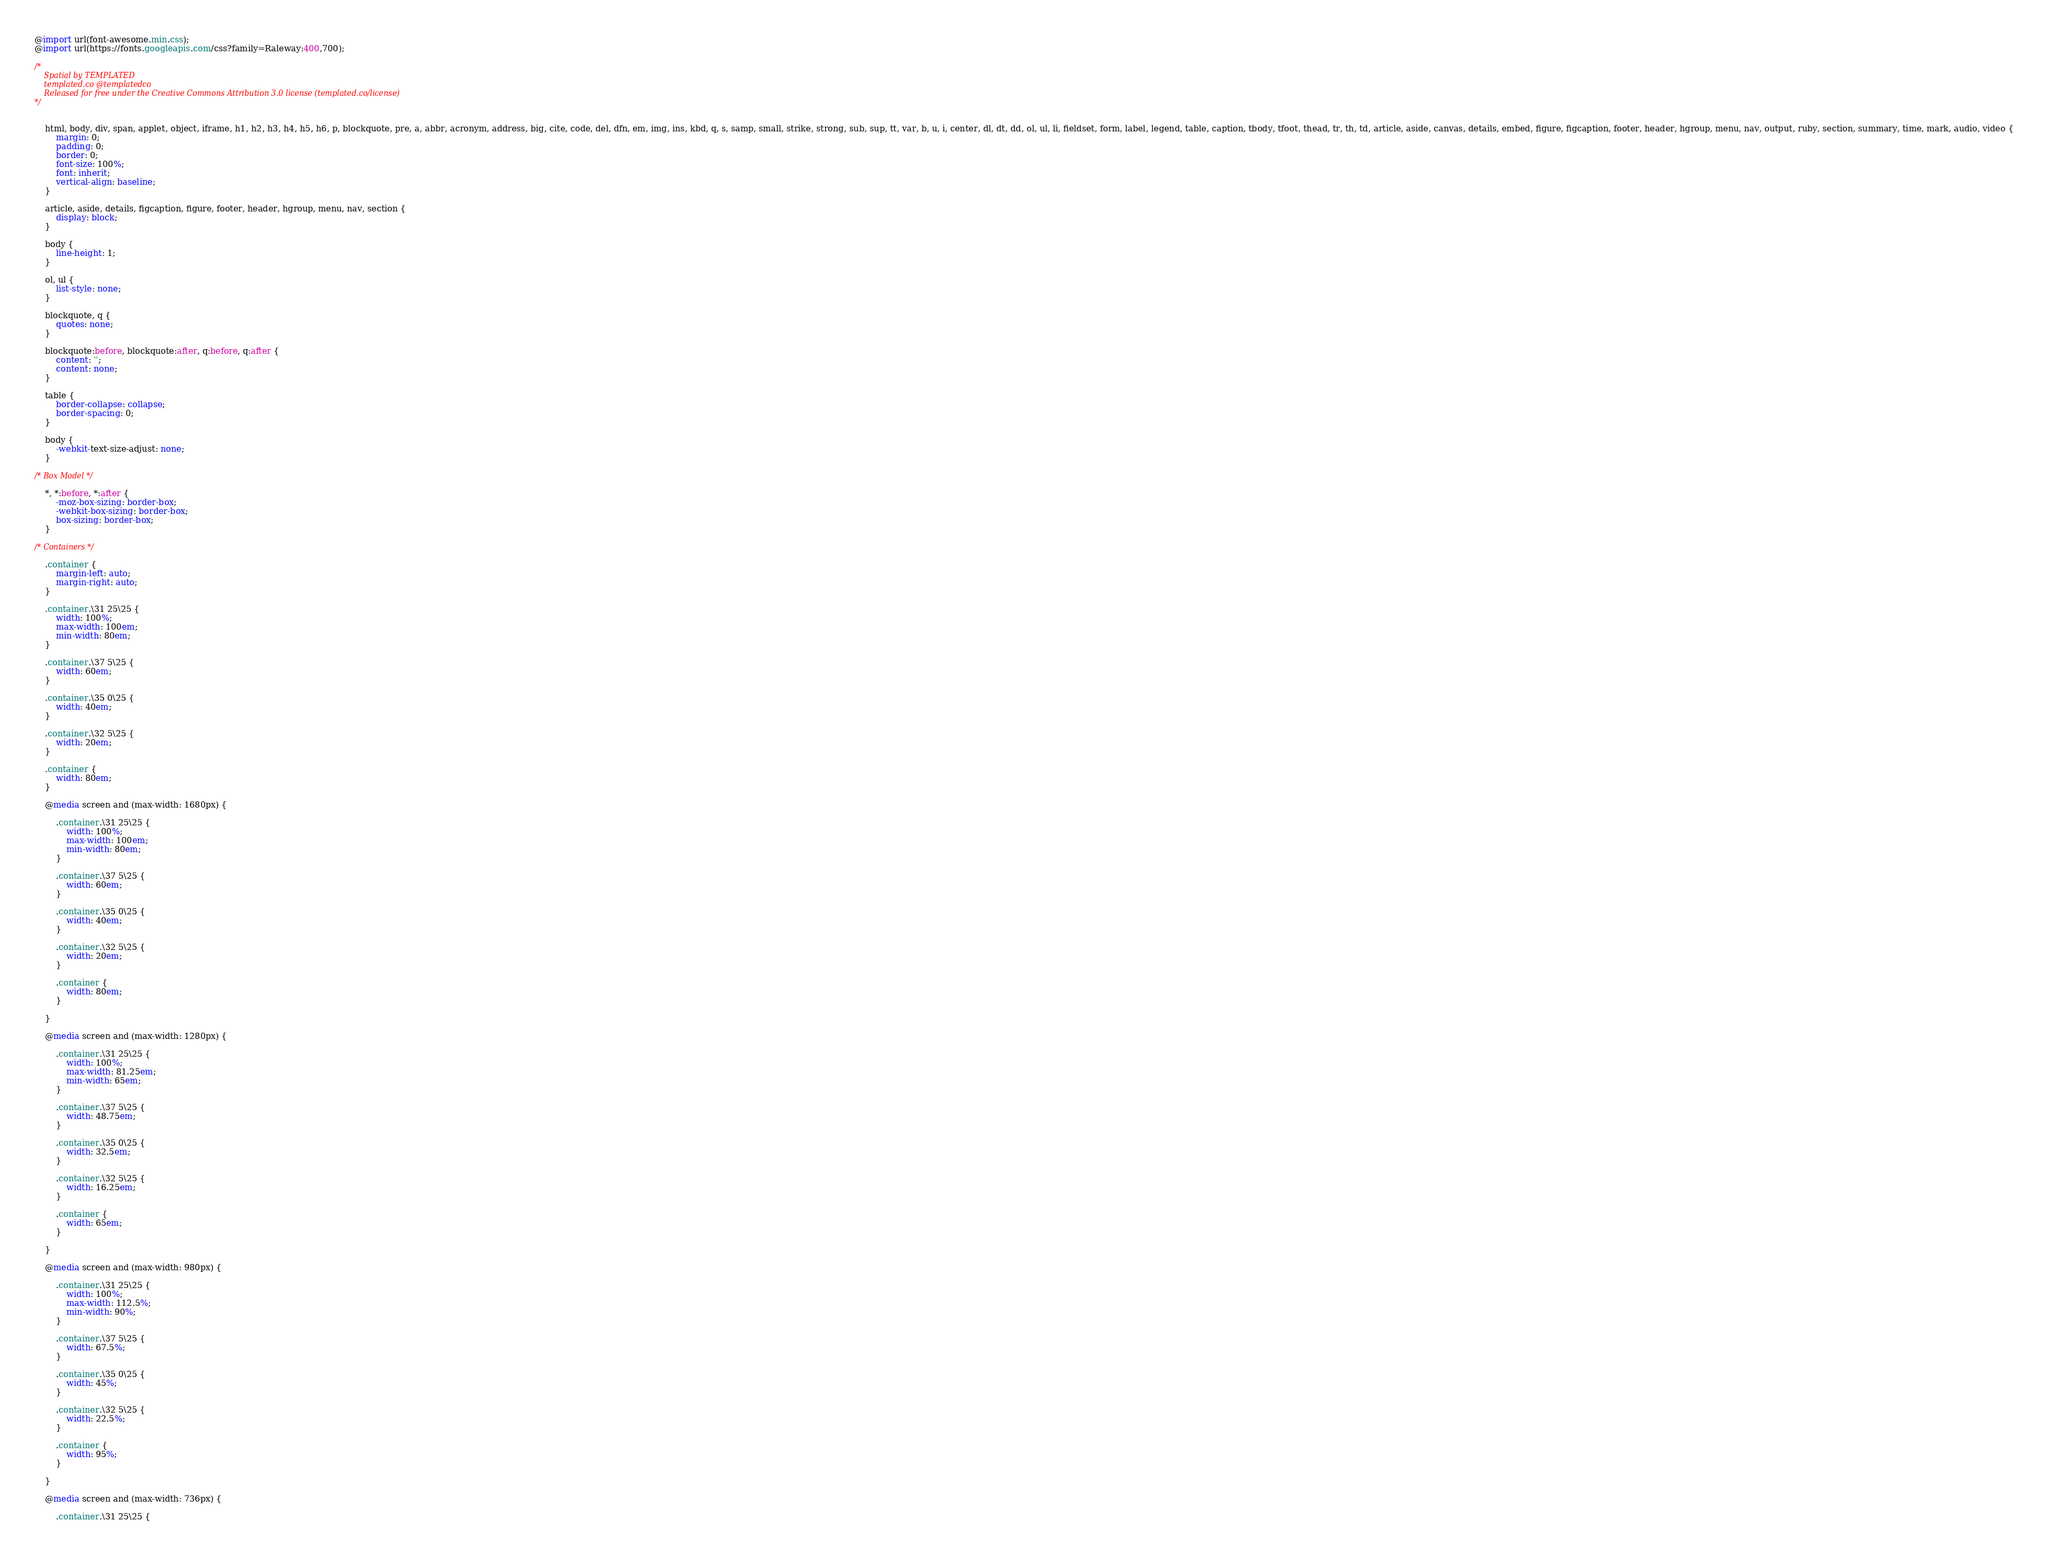Convert code to text. <code><loc_0><loc_0><loc_500><loc_500><_CSS_>@import url(font-awesome.min.css);
@import url(https://fonts.googleapis.com/css?family=Raleway:400,700);

/*
	Spatial by TEMPLATED
	templated.co @templatedco
	Released for free under the Creative Commons Attribution 3.0 license (templated.co/license)
*/


	html, body, div, span, applet, object, iframe, h1, h2, h3, h4, h5, h6, p, blockquote, pre, a, abbr, acronym, address, big, cite, code, del, dfn, em, img, ins, kbd, q, s, samp, small, strike, strong, sub, sup, tt, var, b, u, i, center, dl, dt, dd, ol, ul, li, fieldset, form, label, legend, table, caption, tbody, tfoot, thead, tr, th, td, article, aside, canvas, details, embed, figure, figcaption, footer, header, hgroup, menu, nav, output, ruby, section, summary, time, mark, audio, video {
		margin: 0;
		padding: 0;
		border: 0;
		font-size: 100%;
		font: inherit;
		vertical-align: baseline;
	}

	article, aside, details, figcaption, figure, footer, header, hgroup, menu, nav, section {
		display: block;
	}

	body {
		line-height: 1;
	}

	ol, ul {
		list-style: none;
	}

	blockquote, q {
		quotes: none;
	}

	blockquote:before, blockquote:after, q:before, q:after {
		content: '';
		content: none;
	}

	table {
		border-collapse: collapse;
		border-spacing: 0;
	}

	body {
		-webkit-text-size-adjust: none;
	}

/* Box Model */

	*, *:before, *:after {
		-moz-box-sizing: border-box;
		-webkit-box-sizing: border-box;
		box-sizing: border-box;
	}

/* Containers */

	.container {
		margin-left: auto;
		margin-right: auto;
	}

	.container.\31 25\25 {
		width: 100%;
		max-width: 100em;
		min-width: 80em;
	}

	.container.\37 5\25 {
		width: 60em;
	}

	.container.\35 0\25 {
		width: 40em;
	}

	.container.\32 5\25 {
		width: 20em;
	}

	.container {
		width: 80em;
	}

	@media screen and (max-width: 1680px) {

		.container.\31 25\25 {
			width: 100%;
			max-width: 100em;
			min-width: 80em;
		}

		.container.\37 5\25 {
			width: 60em;
		}

		.container.\35 0\25 {
			width: 40em;
		}

		.container.\32 5\25 {
			width: 20em;
		}

		.container {
			width: 80em;
		}

	}

	@media screen and (max-width: 1280px) {

		.container.\31 25\25 {
			width: 100%;
			max-width: 81.25em;
			min-width: 65em;
		}

		.container.\37 5\25 {
			width: 48.75em;
		}

		.container.\35 0\25 {
			width: 32.5em;
		}

		.container.\32 5\25 {
			width: 16.25em;
		}

		.container {
			width: 65em;
		}

	}

	@media screen and (max-width: 980px) {

		.container.\31 25\25 {
			width: 100%;
			max-width: 112.5%;
			min-width: 90%;
		}

		.container.\37 5\25 {
			width: 67.5%;
		}

		.container.\35 0\25 {
			width: 45%;
		}

		.container.\32 5\25 {
			width: 22.5%;
		}

		.container {
			width: 95%;
		}

	}

	@media screen and (max-width: 736px) {

		.container.\31 25\25 {</code> 